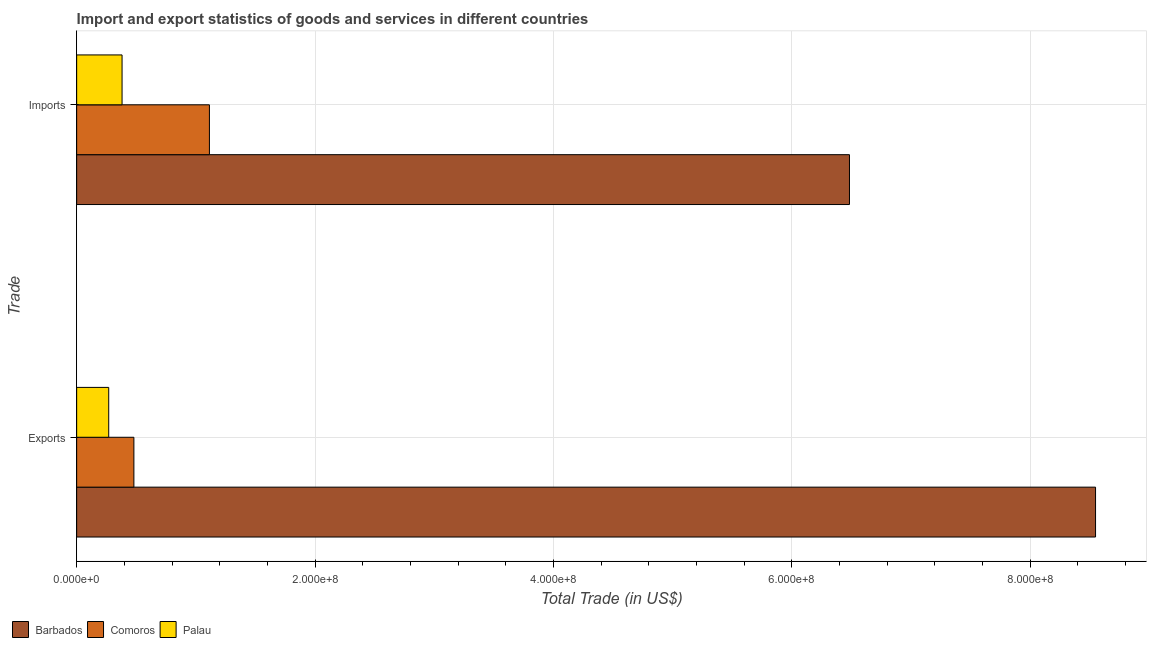How many different coloured bars are there?
Your answer should be compact. 3. What is the label of the 2nd group of bars from the top?
Offer a very short reply. Exports. What is the export of goods and services in Comoros?
Offer a terse response. 4.80e+07. Across all countries, what is the maximum imports of goods and services?
Your answer should be very brief. 6.48e+08. Across all countries, what is the minimum export of goods and services?
Make the answer very short. 2.69e+07. In which country was the imports of goods and services maximum?
Provide a short and direct response. Barbados. In which country was the export of goods and services minimum?
Your answer should be compact. Palau. What is the total export of goods and services in the graph?
Offer a very short reply. 9.30e+08. What is the difference between the export of goods and services in Palau and that in Comoros?
Your response must be concise. -2.11e+07. What is the difference between the export of goods and services in Palau and the imports of goods and services in Comoros?
Make the answer very short. -8.45e+07. What is the average imports of goods and services per country?
Give a very brief answer. 2.66e+08. What is the difference between the export of goods and services and imports of goods and services in Palau?
Provide a succinct answer. -1.12e+07. In how many countries, is the export of goods and services greater than 640000000 US$?
Make the answer very short. 1. What is the ratio of the export of goods and services in Barbados to that in Comoros?
Your answer should be compact. 17.8. In how many countries, is the export of goods and services greater than the average export of goods and services taken over all countries?
Ensure brevity in your answer.  1. What does the 1st bar from the top in Exports represents?
Keep it short and to the point. Palau. What does the 2nd bar from the bottom in Imports represents?
Your answer should be very brief. Comoros. How many countries are there in the graph?
Ensure brevity in your answer.  3. Are the values on the major ticks of X-axis written in scientific E-notation?
Provide a succinct answer. Yes. Does the graph contain any zero values?
Your answer should be compact. No. Where does the legend appear in the graph?
Offer a terse response. Bottom left. How many legend labels are there?
Offer a very short reply. 3. How are the legend labels stacked?
Your answer should be compact. Horizontal. What is the title of the graph?
Keep it short and to the point. Import and export statistics of goods and services in different countries. What is the label or title of the X-axis?
Offer a very short reply. Total Trade (in US$). What is the label or title of the Y-axis?
Your answer should be compact. Trade. What is the Total Trade (in US$) in Barbados in Exports?
Ensure brevity in your answer.  8.55e+08. What is the Total Trade (in US$) in Comoros in Exports?
Your response must be concise. 4.80e+07. What is the Total Trade (in US$) of Palau in Exports?
Your answer should be compact. 2.69e+07. What is the Total Trade (in US$) of Barbados in Imports?
Offer a very short reply. 6.48e+08. What is the Total Trade (in US$) of Comoros in Imports?
Your answer should be very brief. 1.11e+08. What is the Total Trade (in US$) in Palau in Imports?
Provide a succinct answer. 3.81e+07. Across all Trade, what is the maximum Total Trade (in US$) of Barbados?
Offer a very short reply. 8.55e+08. Across all Trade, what is the maximum Total Trade (in US$) of Comoros?
Offer a very short reply. 1.11e+08. Across all Trade, what is the maximum Total Trade (in US$) of Palau?
Provide a succinct answer. 3.81e+07. Across all Trade, what is the minimum Total Trade (in US$) of Barbados?
Give a very brief answer. 6.48e+08. Across all Trade, what is the minimum Total Trade (in US$) of Comoros?
Provide a short and direct response. 4.80e+07. Across all Trade, what is the minimum Total Trade (in US$) of Palau?
Give a very brief answer. 2.69e+07. What is the total Total Trade (in US$) of Barbados in the graph?
Make the answer very short. 1.50e+09. What is the total Total Trade (in US$) of Comoros in the graph?
Keep it short and to the point. 1.59e+08. What is the total Total Trade (in US$) of Palau in the graph?
Your answer should be compact. 6.50e+07. What is the difference between the Total Trade (in US$) in Barbados in Exports and that in Imports?
Ensure brevity in your answer.  2.06e+08. What is the difference between the Total Trade (in US$) in Comoros in Exports and that in Imports?
Your answer should be very brief. -6.34e+07. What is the difference between the Total Trade (in US$) of Palau in Exports and that in Imports?
Give a very brief answer. -1.12e+07. What is the difference between the Total Trade (in US$) in Barbados in Exports and the Total Trade (in US$) in Comoros in Imports?
Ensure brevity in your answer.  7.44e+08. What is the difference between the Total Trade (in US$) in Barbados in Exports and the Total Trade (in US$) in Palau in Imports?
Your answer should be compact. 8.17e+08. What is the difference between the Total Trade (in US$) of Comoros in Exports and the Total Trade (in US$) of Palau in Imports?
Offer a terse response. 9.92e+06. What is the average Total Trade (in US$) in Barbados per Trade?
Offer a terse response. 7.52e+08. What is the average Total Trade (in US$) in Comoros per Trade?
Your answer should be very brief. 7.97e+07. What is the average Total Trade (in US$) in Palau per Trade?
Provide a succinct answer. 3.25e+07. What is the difference between the Total Trade (in US$) of Barbados and Total Trade (in US$) of Comoros in Exports?
Your answer should be compact. 8.07e+08. What is the difference between the Total Trade (in US$) of Barbados and Total Trade (in US$) of Palau in Exports?
Keep it short and to the point. 8.28e+08. What is the difference between the Total Trade (in US$) in Comoros and Total Trade (in US$) in Palau in Exports?
Ensure brevity in your answer.  2.11e+07. What is the difference between the Total Trade (in US$) in Barbados and Total Trade (in US$) in Comoros in Imports?
Your response must be concise. 5.37e+08. What is the difference between the Total Trade (in US$) of Barbados and Total Trade (in US$) of Palau in Imports?
Keep it short and to the point. 6.10e+08. What is the difference between the Total Trade (in US$) of Comoros and Total Trade (in US$) of Palau in Imports?
Your response must be concise. 7.33e+07. What is the ratio of the Total Trade (in US$) in Barbados in Exports to that in Imports?
Your answer should be very brief. 1.32. What is the ratio of the Total Trade (in US$) of Comoros in Exports to that in Imports?
Offer a very short reply. 0.43. What is the ratio of the Total Trade (in US$) in Palau in Exports to that in Imports?
Provide a succinct answer. 0.71. What is the difference between the highest and the second highest Total Trade (in US$) of Barbados?
Your response must be concise. 2.06e+08. What is the difference between the highest and the second highest Total Trade (in US$) of Comoros?
Ensure brevity in your answer.  6.34e+07. What is the difference between the highest and the second highest Total Trade (in US$) of Palau?
Offer a very short reply. 1.12e+07. What is the difference between the highest and the lowest Total Trade (in US$) in Barbados?
Your answer should be very brief. 2.06e+08. What is the difference between the highest and the lowest Total Trade (in US$) of Comoros?
Keep it short and to the point. 6.34e+07. What is the difference between the highest and the lowest Total Trade (in US$) of Palau?
Your answer should be compact. 1.12e+07. 